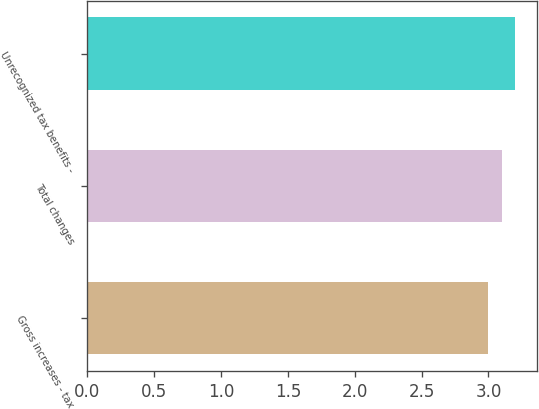<chart> <loc_0><loc_0><loc_500><loc_500><bar_chart><fcel>Gross increases - tax<fcel>Total changes<fcel>Unrecognized tax benefits -<nl><fcel>3<fcel>3.1<fcel>3.2<nl></chart> 